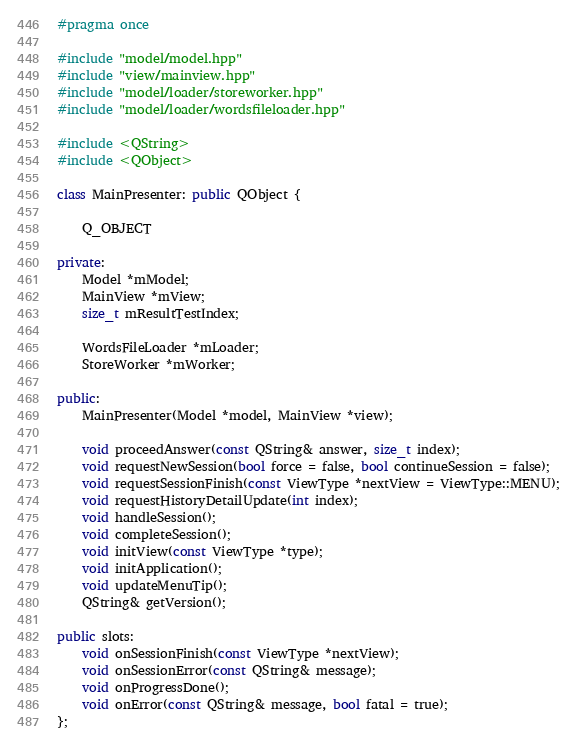Convert code to text. <code><loc_0><loc_0><loc_500><loc_500><_C++_>#pragma once

#include "model/model.hpp"
#include "view/mainview.hpp"
#include "model/loader/storeworker.hpp"
#include "model/loader/wordsfileloader.hpp"

#include <QString>
#include <QObject>

class MainPresenter: public QObject {

    Q_OBJECT

private:
    Model *mModel;
    MainView *mView;
    size_t mResultTestIndex;

    WordsFileLoader *mLoader;
    StoreWorker *mWorker;

public:
    MainPresenter(Model *model, MainView *view);

    void proceedAnswer(const QString& answer, size_t index);
    void requestNewSession(bool force = false, bool continueSession = false);
    void requestSessionFinish(const ViewType *nextView = ViewType::MENU);
    void requestHistoryDetailUpdate(int index);
    void handleSession();
    void completeSession();
    void initView(const ViewType *type);
    void initApplication();
    void updateMenuTip();
    QString& getVersion();

public slots:
    void onSessionFinish(const ViewType *nextView);
    void onSessionError(const QString& message);
    void onProgressDone();
    void onError(const QString& message, bool fatal = true);
};
</code> 